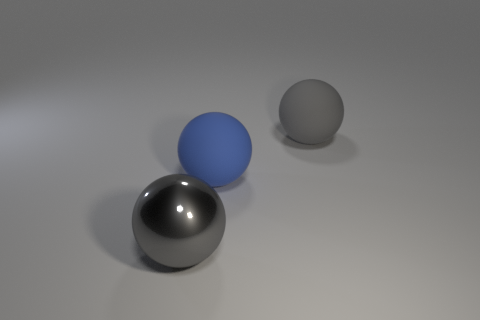Subtract all yellow cylinders. How many gray spheres are left? 2 Subtract all gray balls. How many balls are left? 1 Add 2 big blue cylinders. How many objects exist? 5 Subtract all tiny blue matte cylinders. Subtract all big gray metallic objects. How many objects are left? 2 Add 2 gray rubber objects. How many gray rubber objects are left? 3 Add 1 gray things. How many gray things exist? 3 Subtract 0 red cubes. How many objects are left? 3 